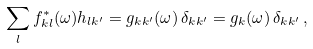Convert formula to latex. <formula><loc_0><loc_0><loc_500><loc_500>\sum _ { l } f ^ { * } _ { k l } ( \omega ) h _ { l k ^ { \prime } } = g _ { k k ^ { \prime } } ( \omega ) \, \delta _ { k k ^ { \prime } } = g _ { k } ( \omega ) \, \delta _ { k k ^ { \prime } } \, ,</formula> 